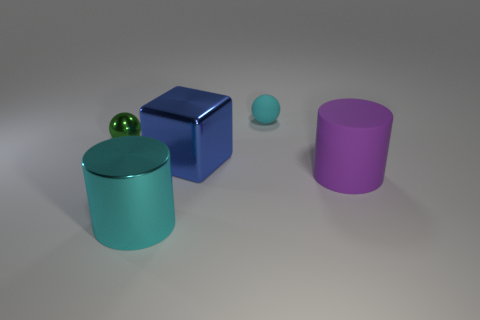What size is the shiny cylinder that is the same color as the matte ball?
Your answer should be compact. Large. Are there the same number of cyan shiny things that are in front of the cyan cylinder and tiny shiny things?
Your response must be concise. No. Are the big cylinder on the right side of the blue block and the large blue object made of the same material?
Keep it short and to the point. No. Are there fewer rubber cylinders left of the blue block than metal cubes?
Give a very brief answer. Yes. What number of rubber things are either small cyan balls or big green blocks?
Your answer should be very brief. 1. Do the metal cylinder and the large rubber thing have the same color?
Give a very brief answer. No. Is there any other thing of the same color as the rubber ball?
Your answer should be compact. Yes. Is the shape of the rubber object that is in front of the small green shiny ball the same as the metallic object that is on the left side of the large cyan thing?
Your answer should be compact. No. What number of things are big green balls or objects that are in front of the small green shiny sphere?
Offer a very short reply. 3. What number of other objects are the same size as the rubber sphere?
Give a very brief answer. 1. 